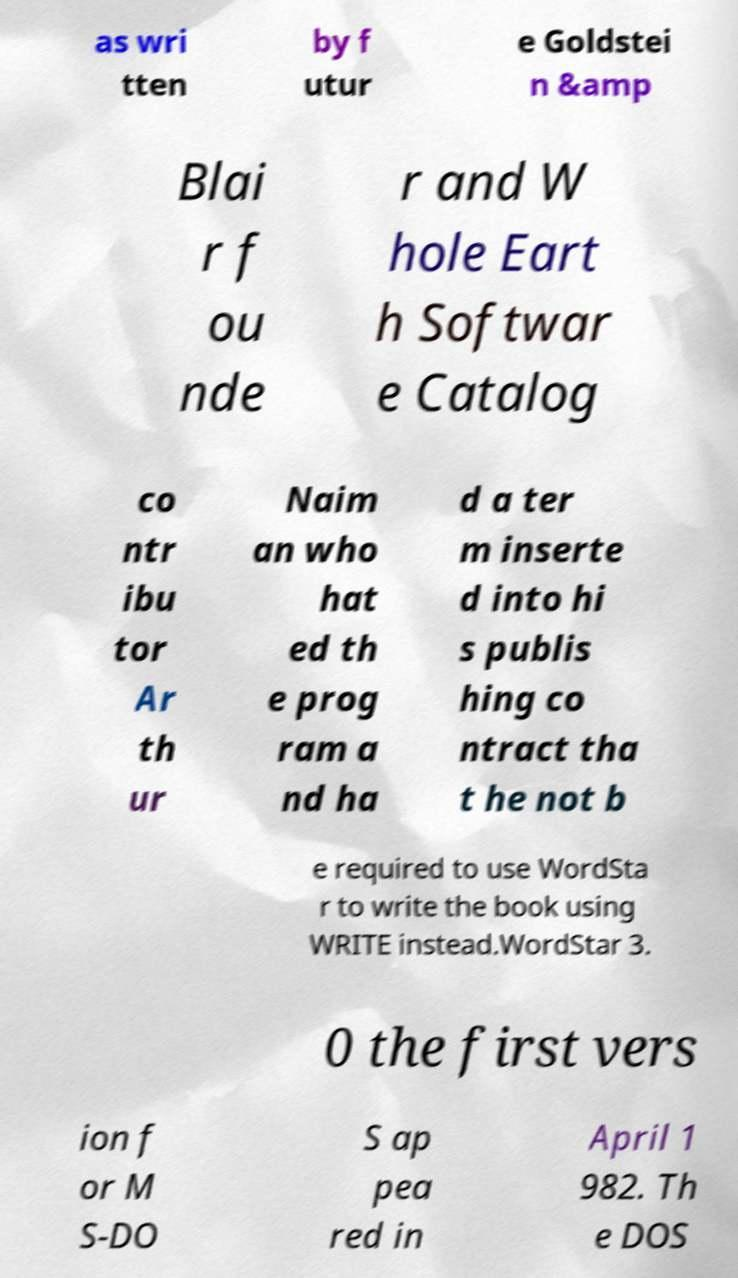Could you assist in decoding the text presented in this image and type it out clearly? as wri tten by f utur e Goldstei n &amp Blai r f ou nde r and W hole Eart h Softwar e Catalog co ntr ibu tor Ar th ur Naim an who hat ed th e prog ram a nd ha d a ter m inserte d into hi s publis hing co ntract tha t he not b e required to use WordSta r to write the book using WRITE instead.WordStar 3. 0 the first vers ion f or M S-DO S ap pea red in April 1 982. Th e DOS 